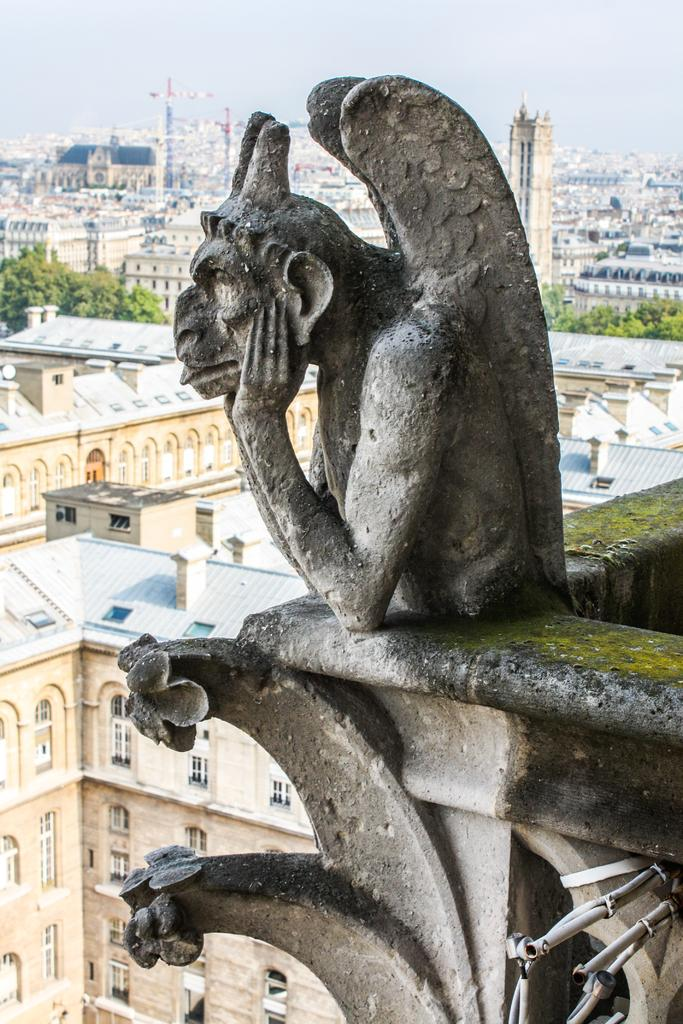What is the main subject in the image? There is a statue in the image. What else can be seen in the image besides the statue? There are buildings, trees, and some objects in the image. Can you describe the background of the image? The sky is visible in the background of the image. How many rabbits can be seen playing with the statue in the image? There are no rabbits present in the image. What type of nose is featured on the statue in the image? The statue in the image does not have a nose, as it is not a human figure. 